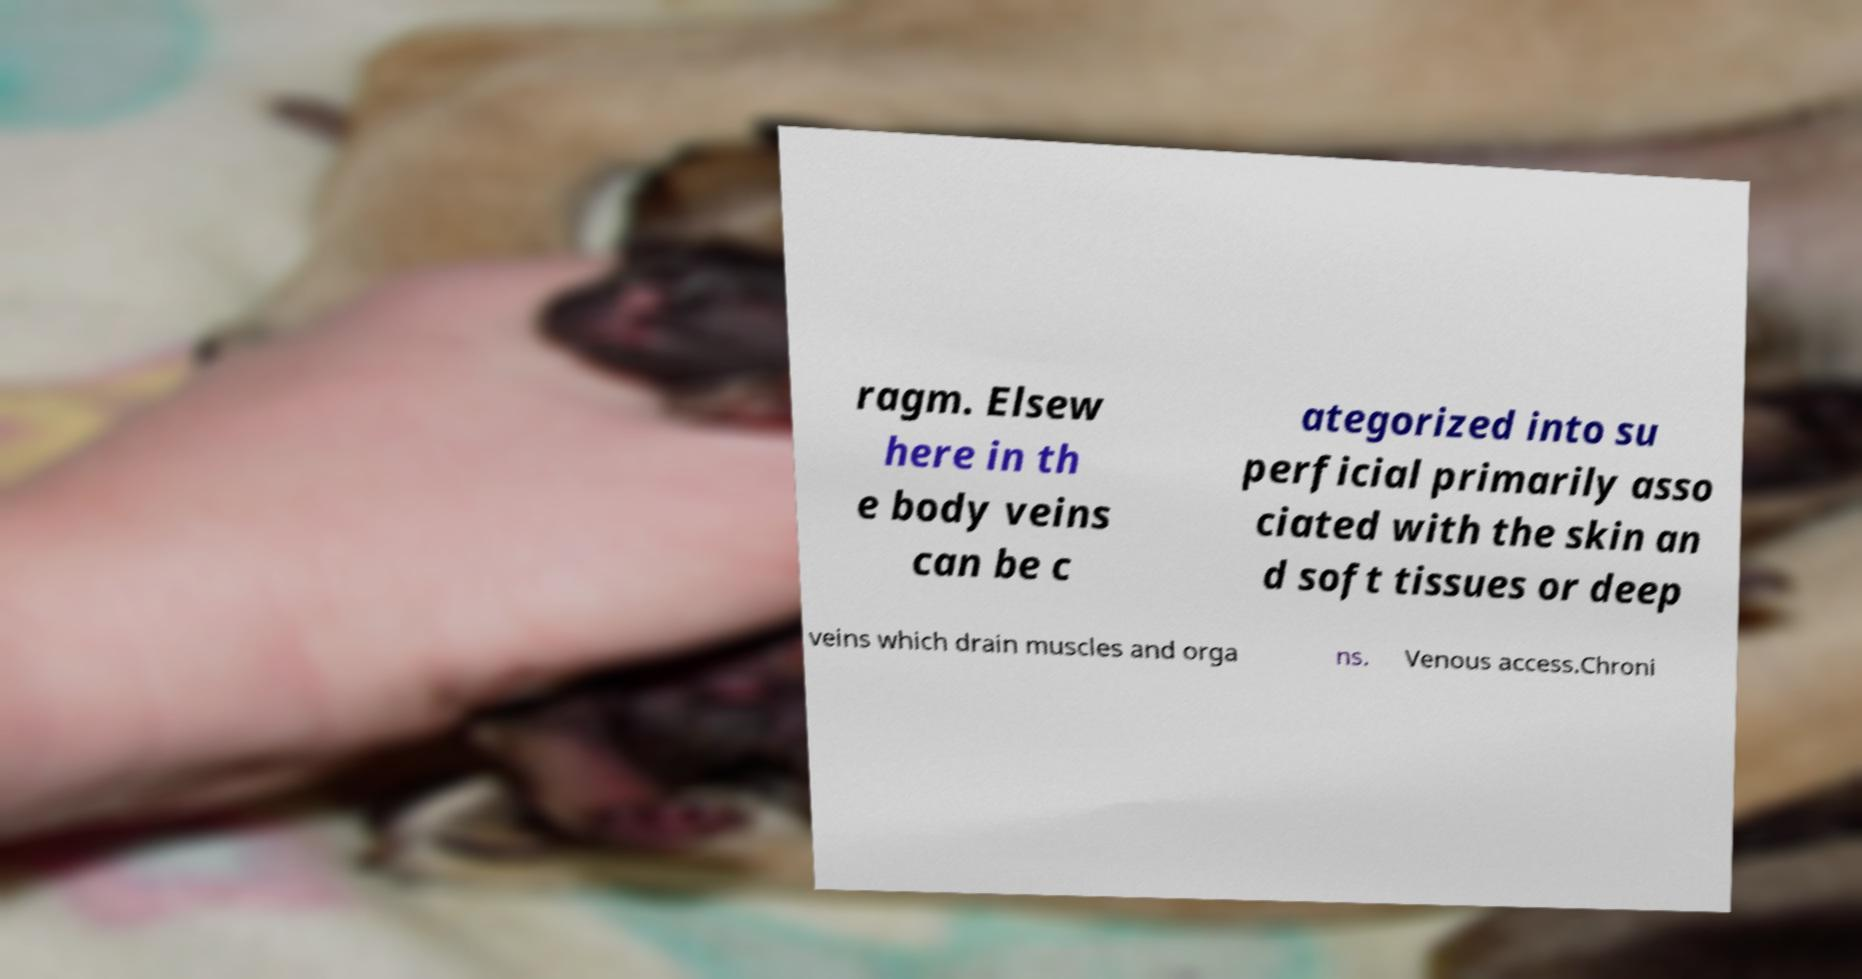Can you read and provide the text displayed in the image?This photo seems to have some interesting text. Can you extract and type it out for me? ragm. Elsew here in th e body veins can be c ategorized into su perficial primarily asso ciated with the skin an d soft tissues or deep veins which drain muscles and orga ns. Venous access.Chroni 